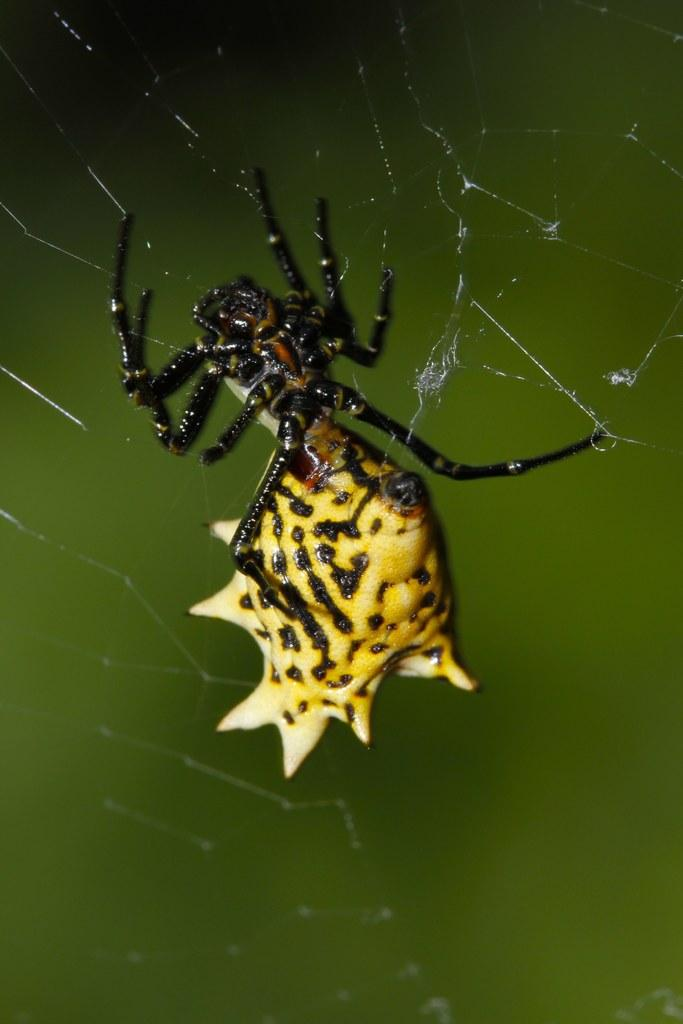What is the main subject in the center of the image? There is a spider in the center of the image. What else can be seen in the image besides the spider? There is a net in the image. What type of apparel is the spider wearing on its leg in the image? There is no apparel present in the image, and spiders do not wear clothing. 